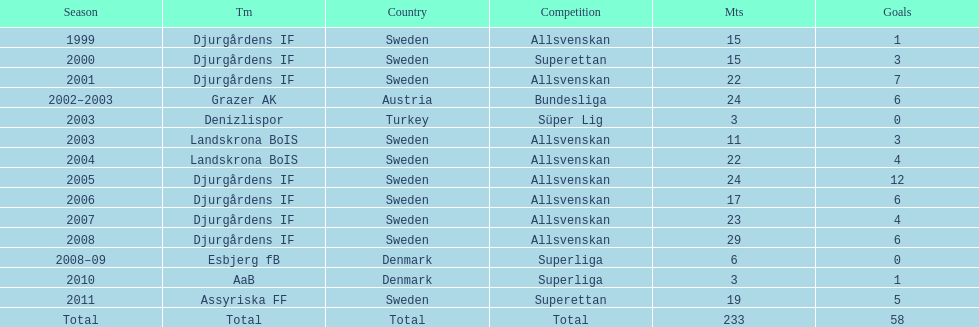What team has the most goals? Djurgårdens IF. 